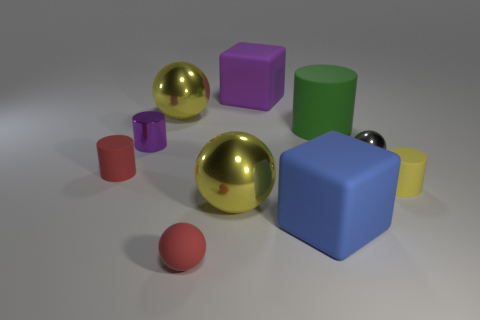Subtract 1 cylinders. How many cylinders are left? 3 Subtract all tiny matte spheres. How many spheres are left? 3 Subtract all brown spheres. How many brown cylinders are left? 0 Subtract all blue blocks. How many blocks are left? 1 Subtract 0 cyan cylinders. How many objects are left? 10 Subtract all spheres. How many objects are left? 6 Subtract all yellow cylinders. Subtract all yellow balls. How many cylinders are left? 3 Subtract all tiny rubber balls. Subtract all purple objects. How many objects are left? 7 Add 8 blue rubber cubes. How many blue rubber cubes are left? 9 Add 1 gray balls. How many gray balls exist? 2 